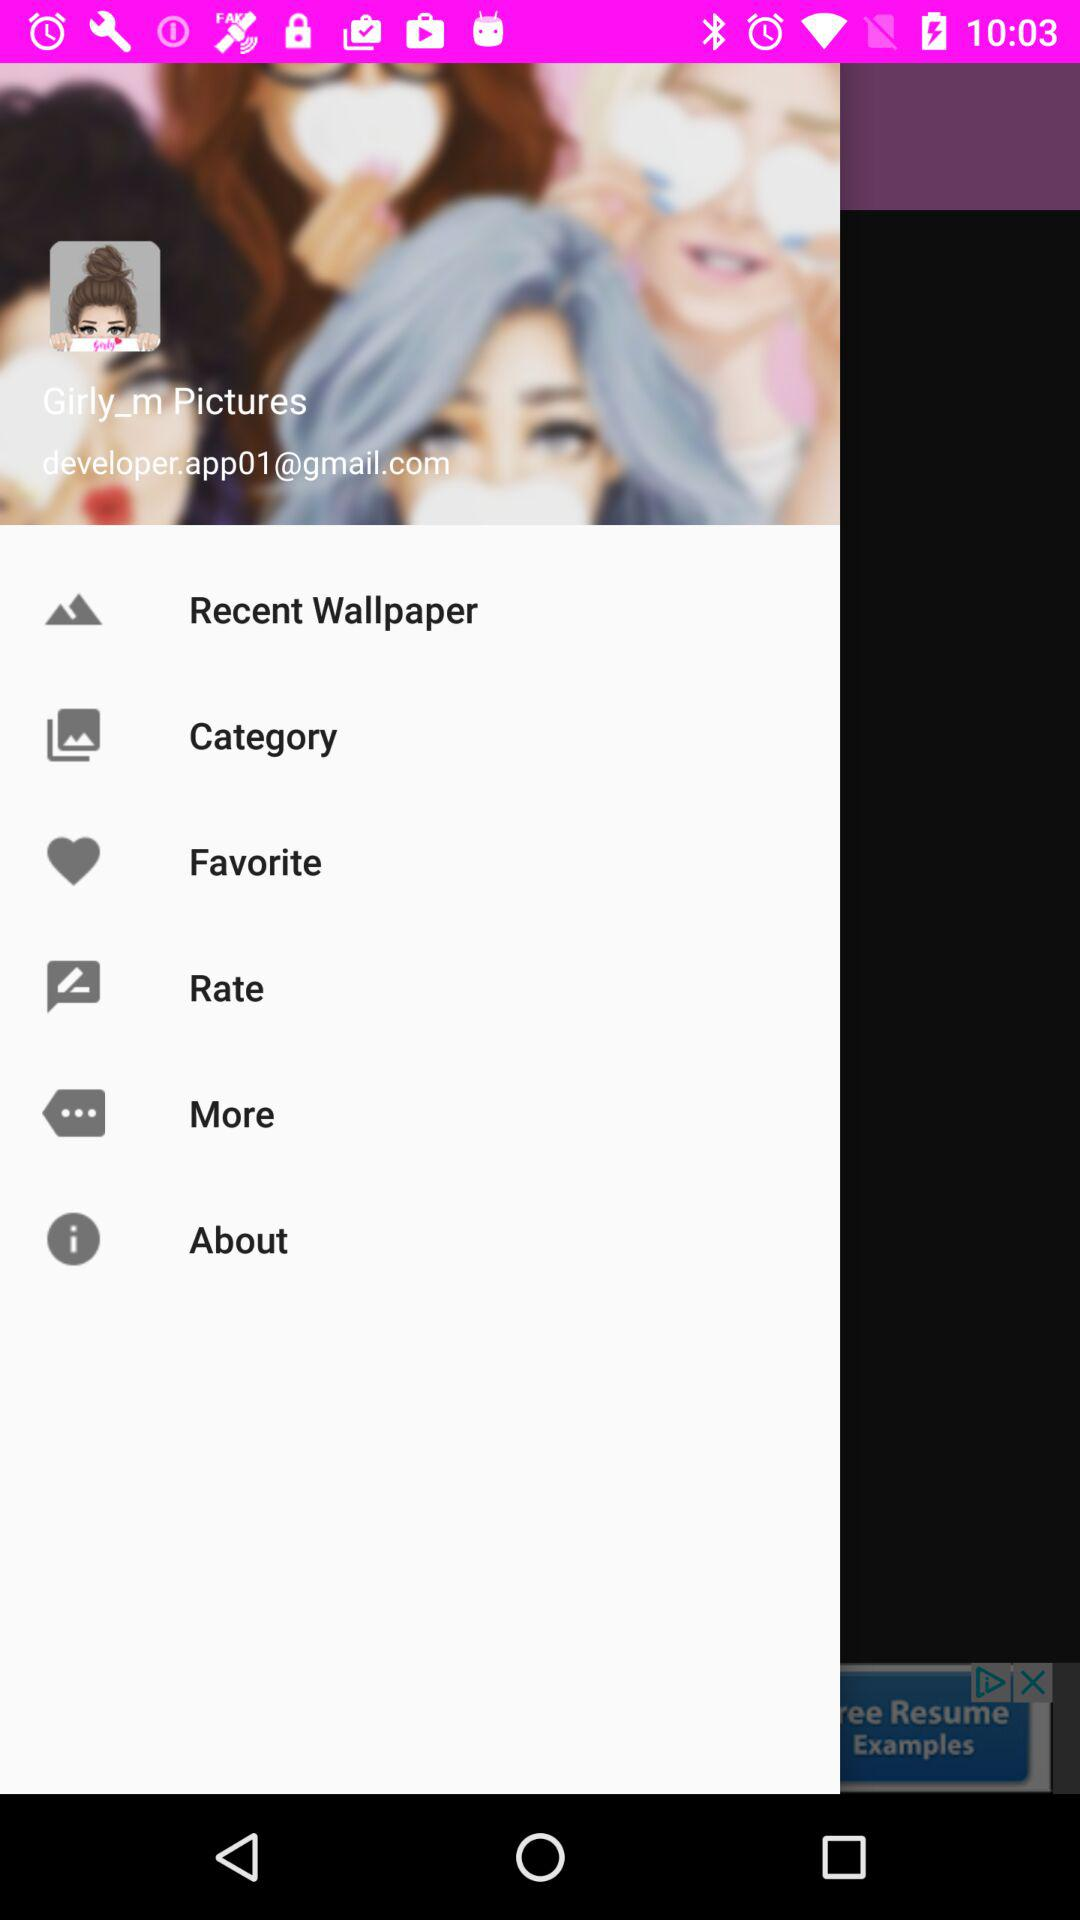What is the user name?
When the provided information is insufficient, respond with <no answer>. <no answer> 